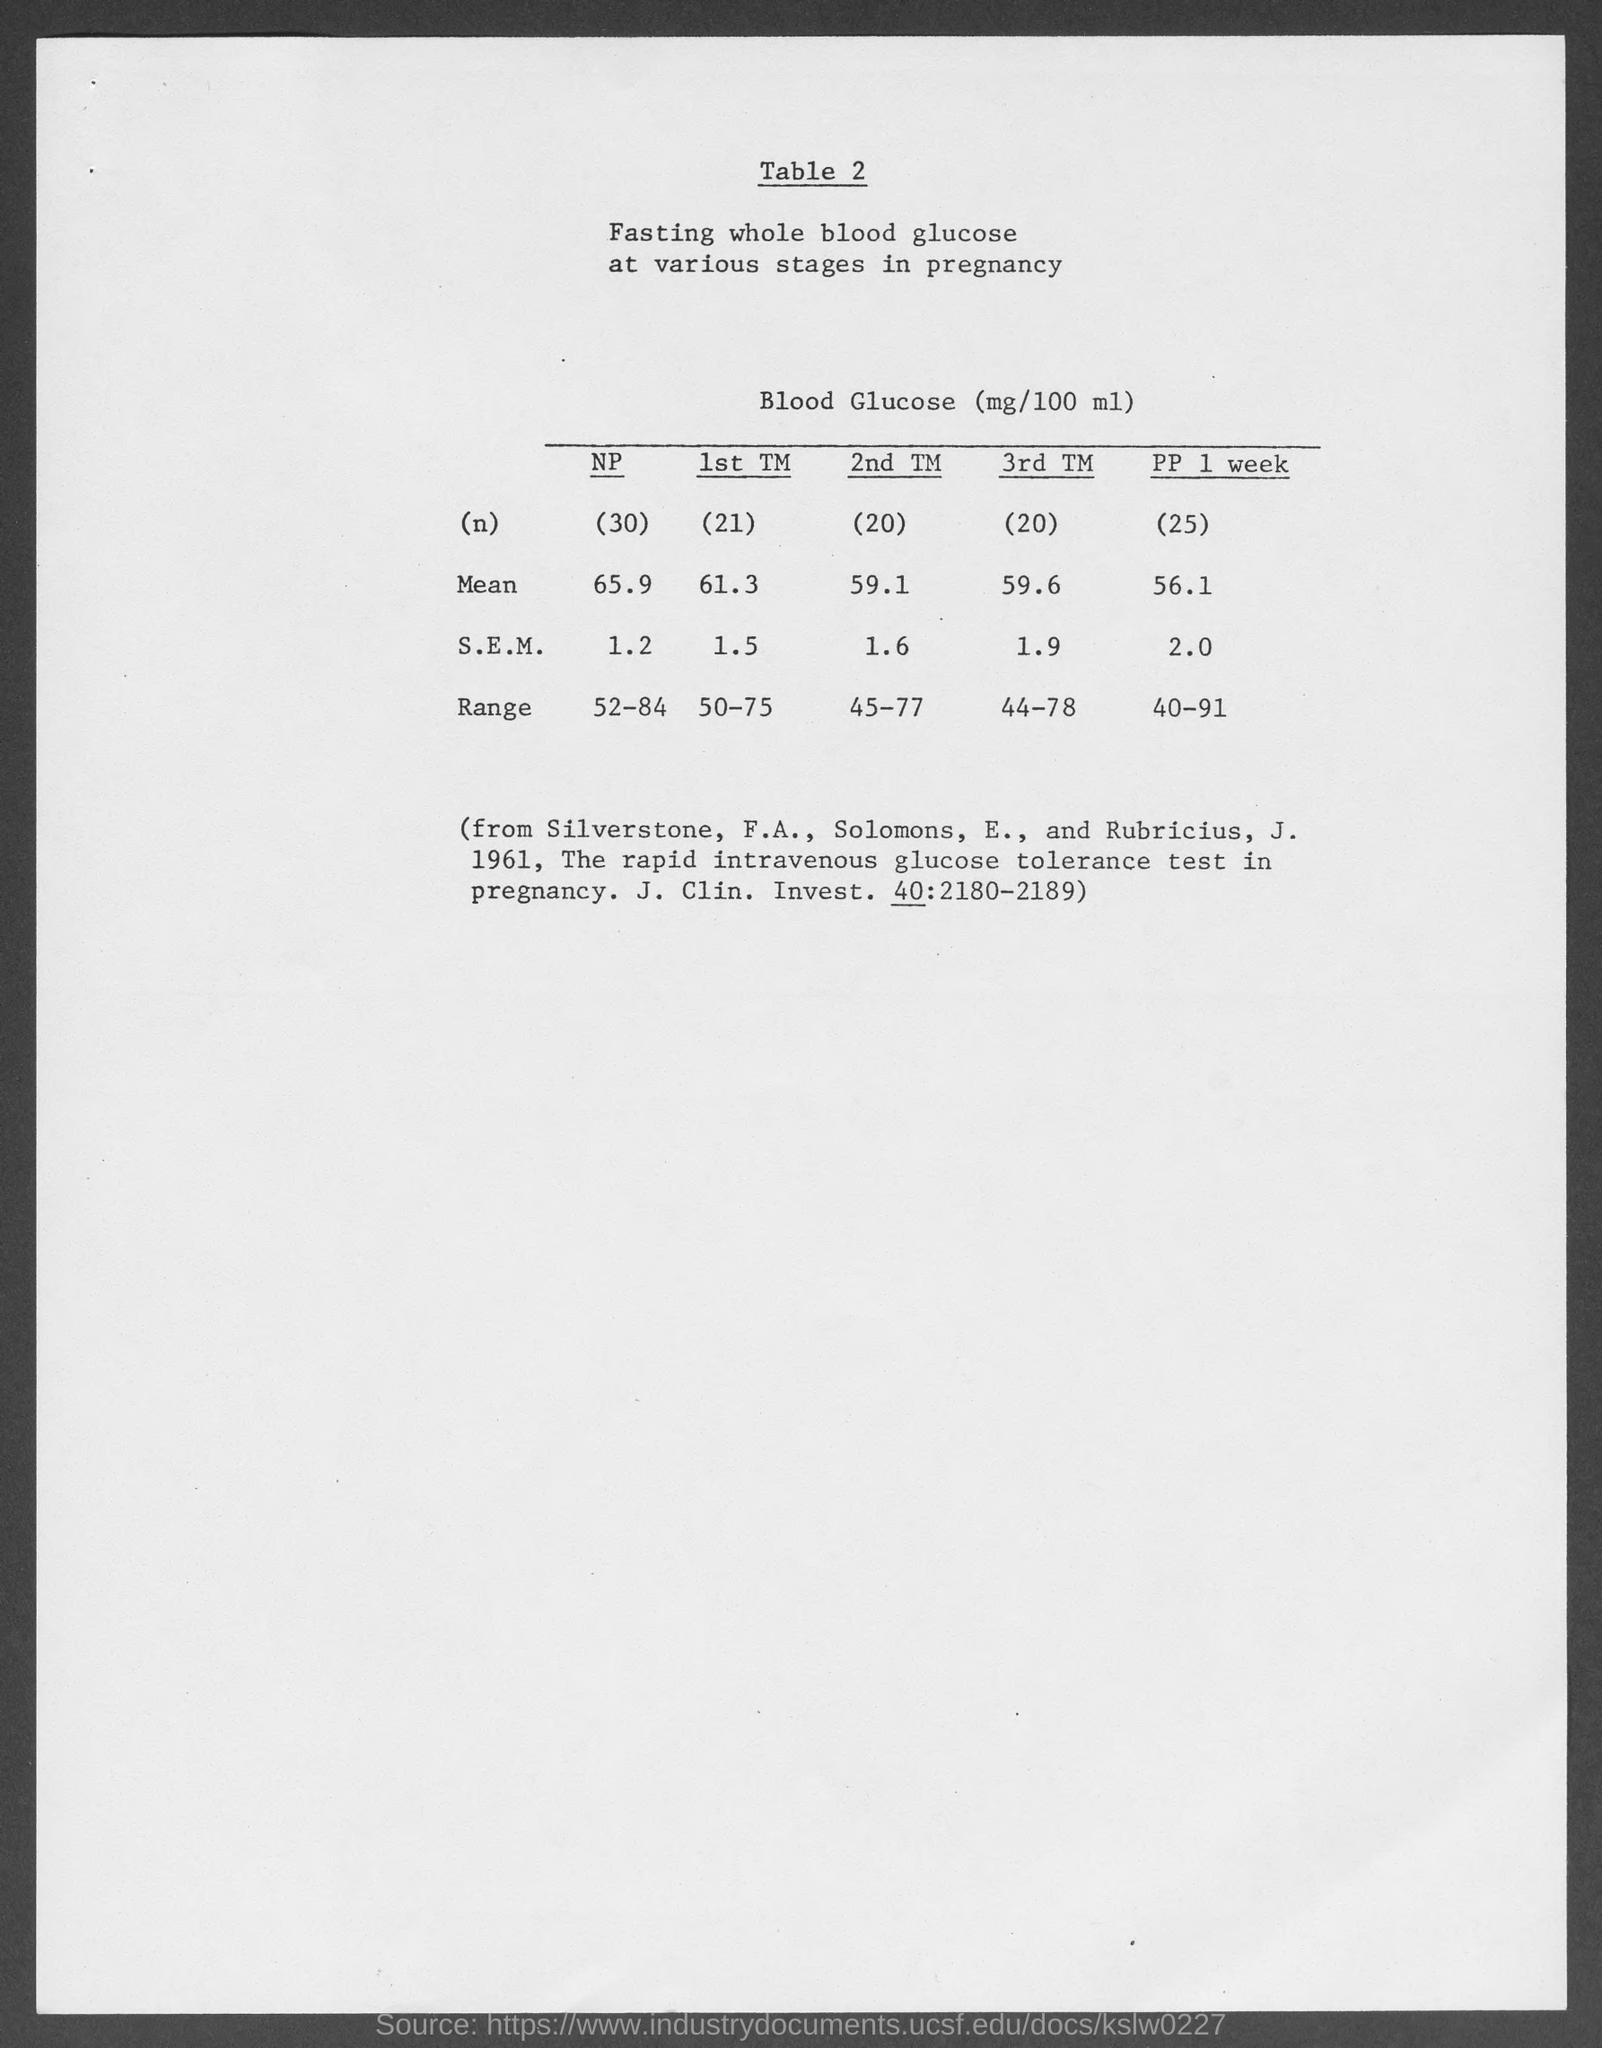What is the mean value of 1st TM?
 61.3 